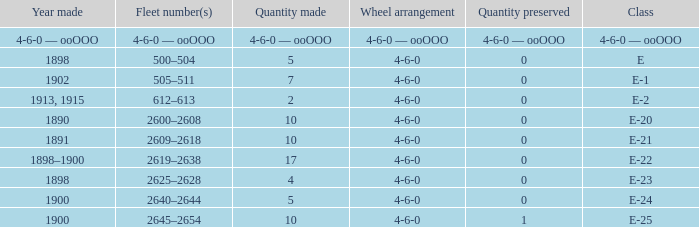What is the wheel arrangement with 1 quantity preserved? 4-6-0. 